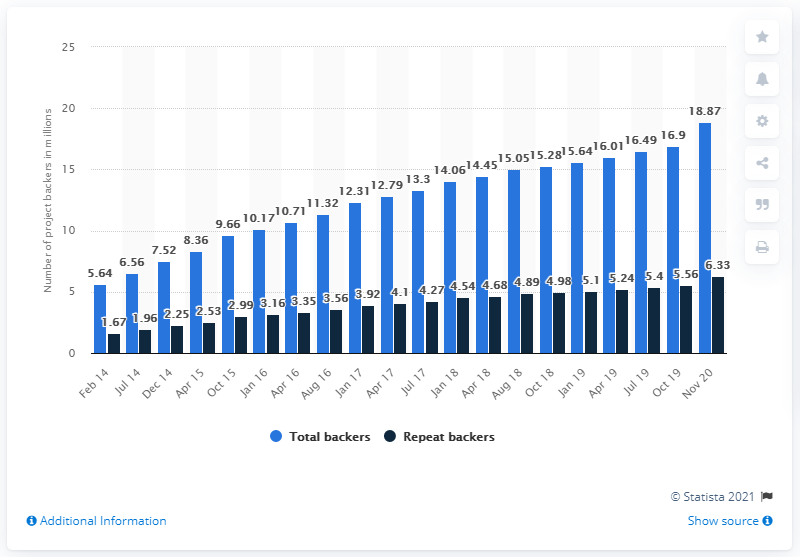Give some essential details in this illustration. Out of the total number of backers, 6.33% had backed more than one project. As of November 19, 2020, there were 18,870 people who had pledged their monetary support towards at least one of the 500,000 projects launched on the Kickstarter platform. 